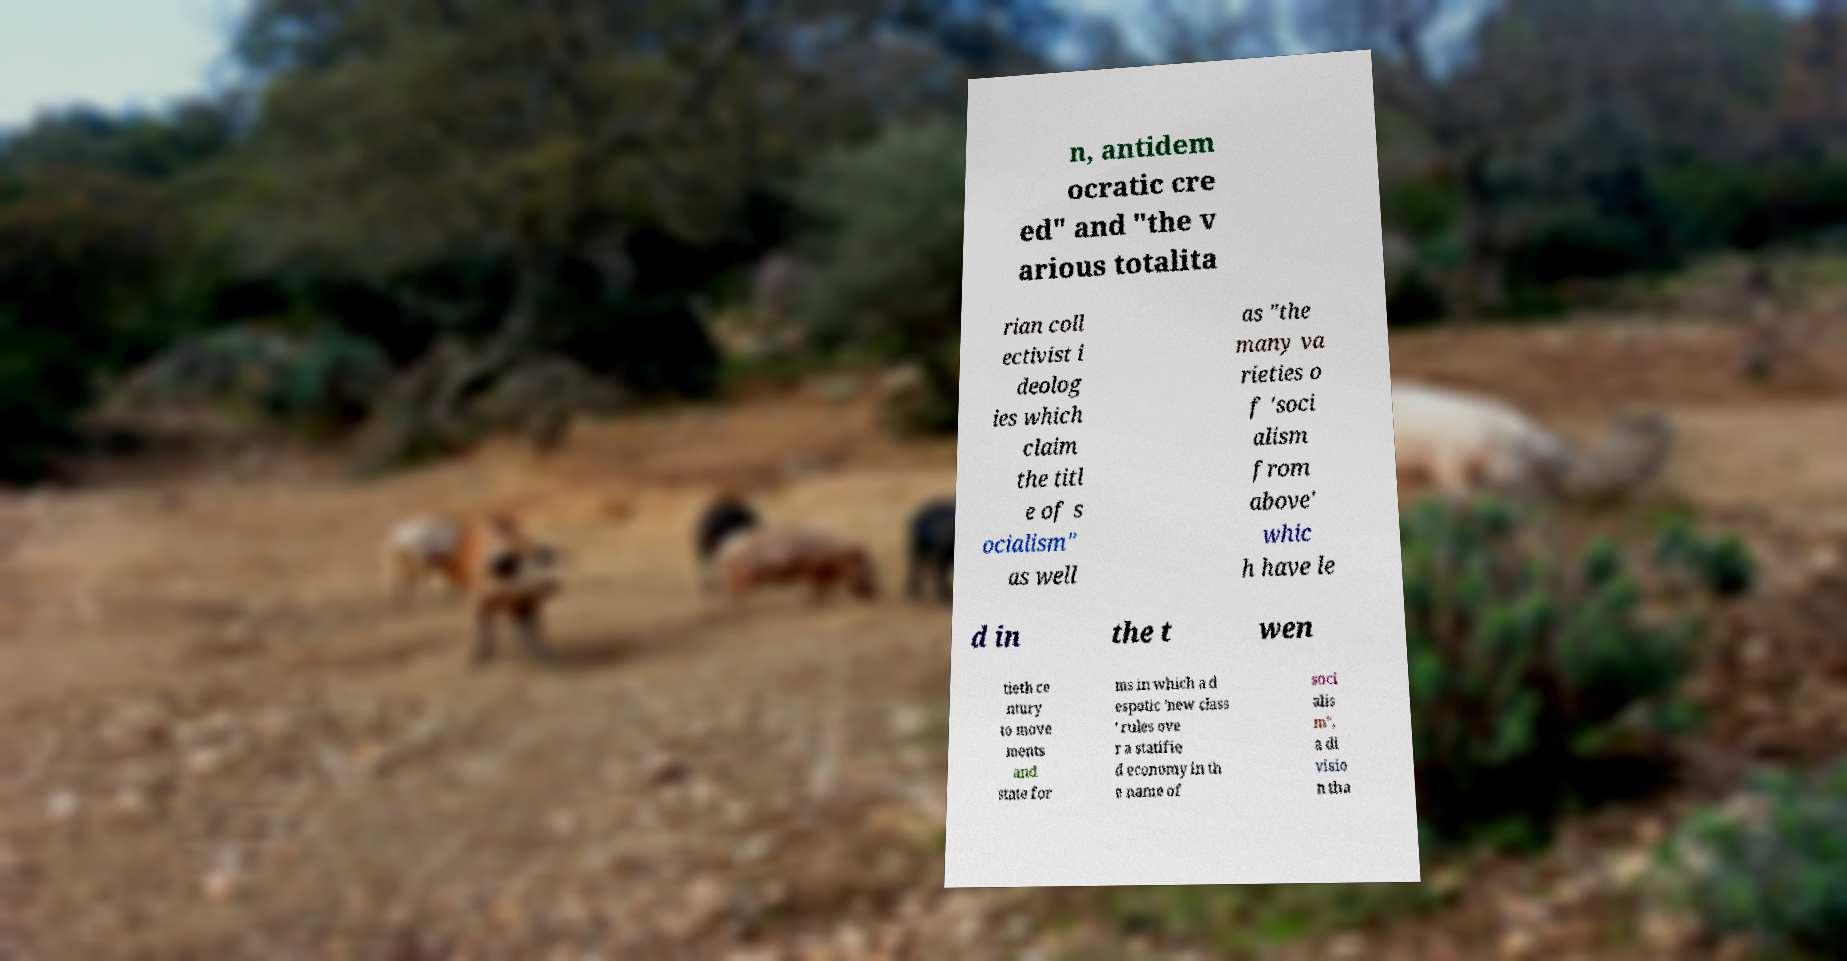For documentation purposes, I need the text within this image transcribed. Could you provide that? n, antidem ocratic cre ed" and "the v arious totalita rian coll ectivist i deolog ies which claim the titl e of s ocialism" as well as "the many va rieties o f 'soci alism from above' whic h have le d in the t wen tieth ce ntury to move ments and state for ms in which a d espotic 'new class ' rules ove r a statifie d economy in th e name of soci alis m", a di visio n tha 